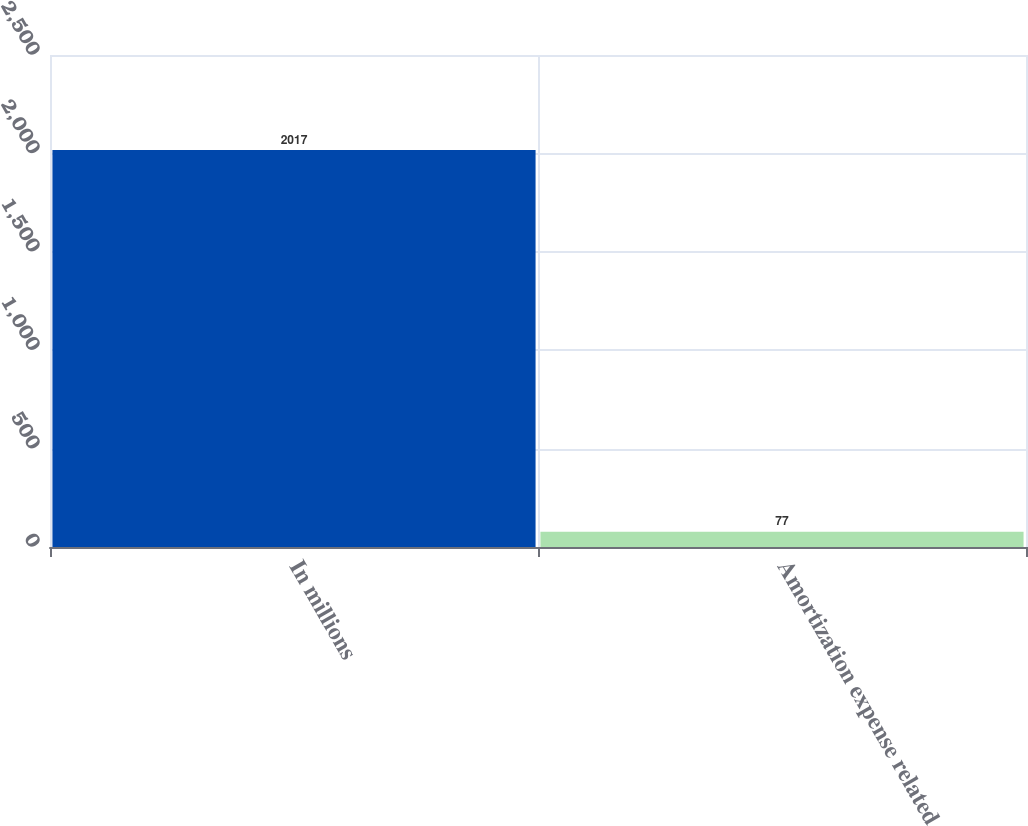Convert chart to OTSL. <chart><loc_0><loc_0><loc_500><loc_500><bar_chart><fcel>In millions<fcel>Amortization expense related<nl><fcel>2017<fcel>77<nl></chart> 